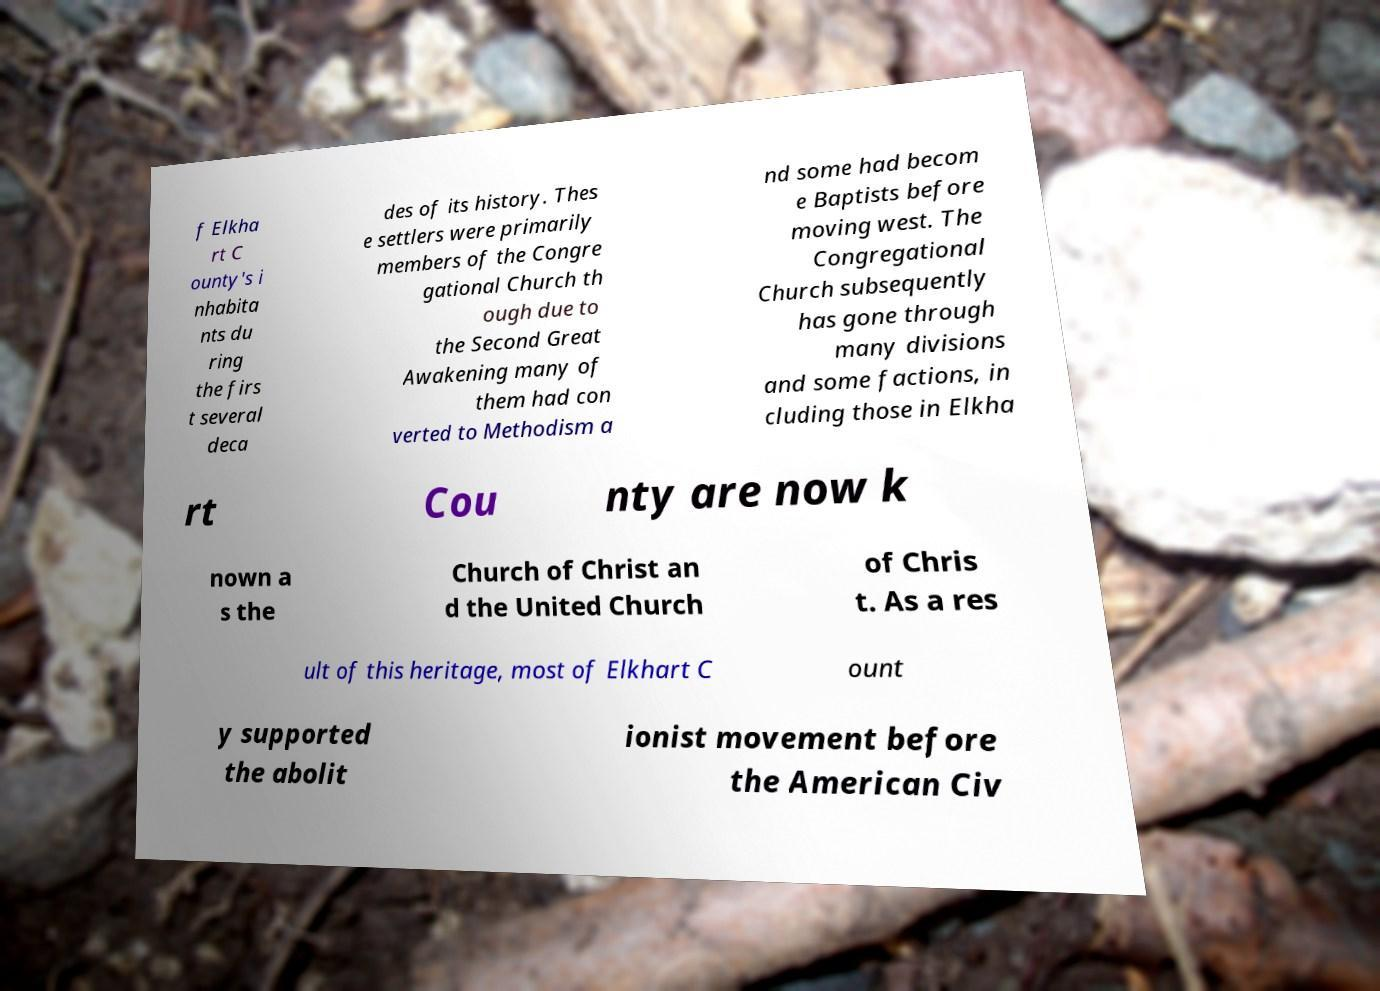Could you assist in decoding the text presented in this image and type it out clearly? f Elkha rt C ounty's i nhabita nts du ring the firs t several deca des of its history. Thes e settlers were primarily members of the Congre gational Church th ough due to the Second Great Awakening many of them had con verted to Methodism a nd some had becom e Baptists before moving west. The Congregational Church subsequently has gone through many divisions and some factions, in cluding those in Elkha rt Cou nty are now k nown a s the Church of Christ an d the United Church of Chris t. As a res ult of this heritage, most of Elkhart C ount y supported the abolit ionist movement before the American Civ 